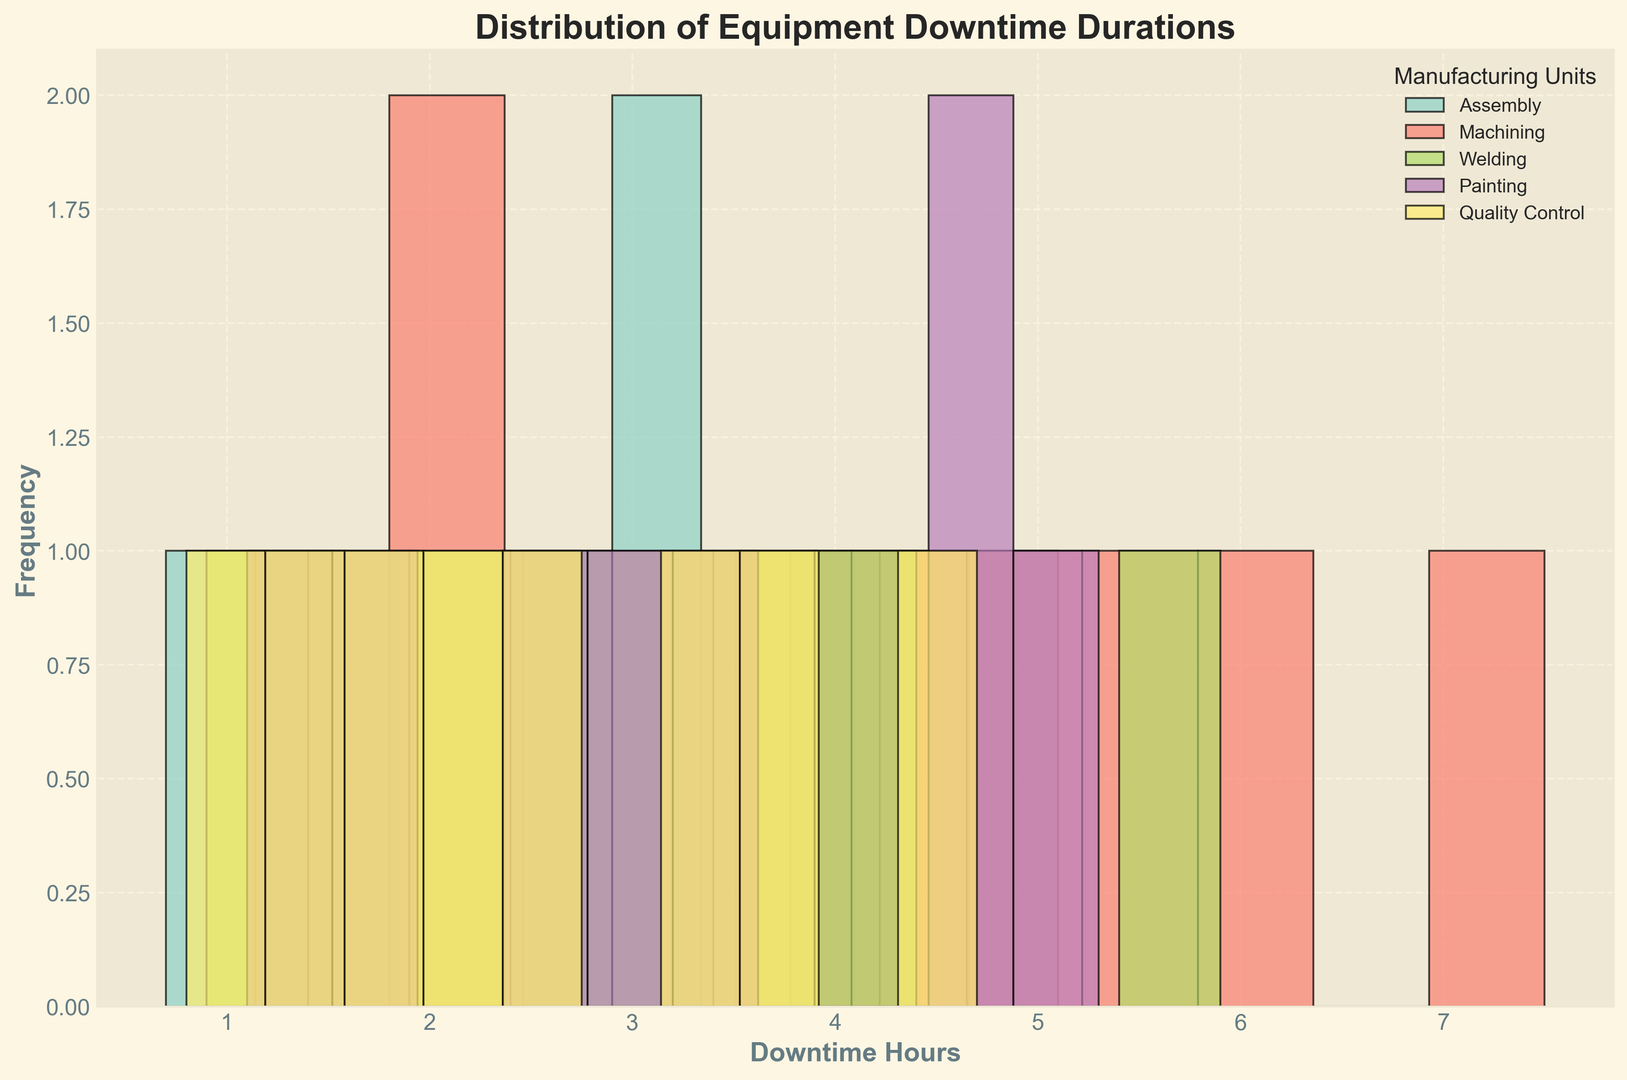What is the most frequent range of downtime hours for the Assembly unit? First, identify the bars representing the Assembly unit in the histogram. Then, observe which range has the highest bar (most frequency).
Answer: 2-3 hours Which manufacturing unit has the longest downtime? Look at the highest value on the x-axis for each color representing different units, and identify the unit corresponding to the longest downtime.
Answer: Machining What is the average downtime duration for the Welding unit? Calculate the average by summing up the downtime durations for the Welding unit (1.5 + 3.7 + 2.3 + 5.9 + 4.1 + 0.9 + 3.2 + 2.8) and dividing by the number of instances (8). (24.4 / 8 = 3.05)
Answer: 3.05 hours Between Assembly and Painting units, which has more instances of equipment downtimes lasting between 3 and 4 hours? Refer to the bars in the 3-4 hours range for both Assembly and Painting units, and compare their heights (frequencies).
Answer: Assembly Do any of the units have downtimes that are less than 1 hour? Look for the presence of bars in the <1 hour range for each color representing different units. If a bar is present, it means that the unit has downtime durations less than 1 hour.
Answer: Yes Which unit has the most diverse distribution of downtime durations (more spread across different ranges)? Identify which unit's histogram bars extend across more downtime ranges (more x-axis coverage).
Answer: Machining What is the highest frequency of downtime durations observed for any single unit? Look for the highest bar in the entire histogram and note its frequency (y-axis value).
Answer: 4 Is the downtime duration distribution for Quality Control unit skewed towards shorter or longer durations? Observe the distribution of bars for the Quality Control unit. If bars are higher on the left (shorter durations), it is skewed towards shorter durations; if higher on the right (longer durations), it is skewed towards longer durations.
Answer: Shorter durations Compare the downtime distributions between the Assembly and Machining units. Which unit has a more uniform distribution? Compare the shape and spread of the bars for Assembly and Machining units. For a unit to have a more uniform distribution, the bars should be more evenly spaced and similar in height.
Answer: Machining 